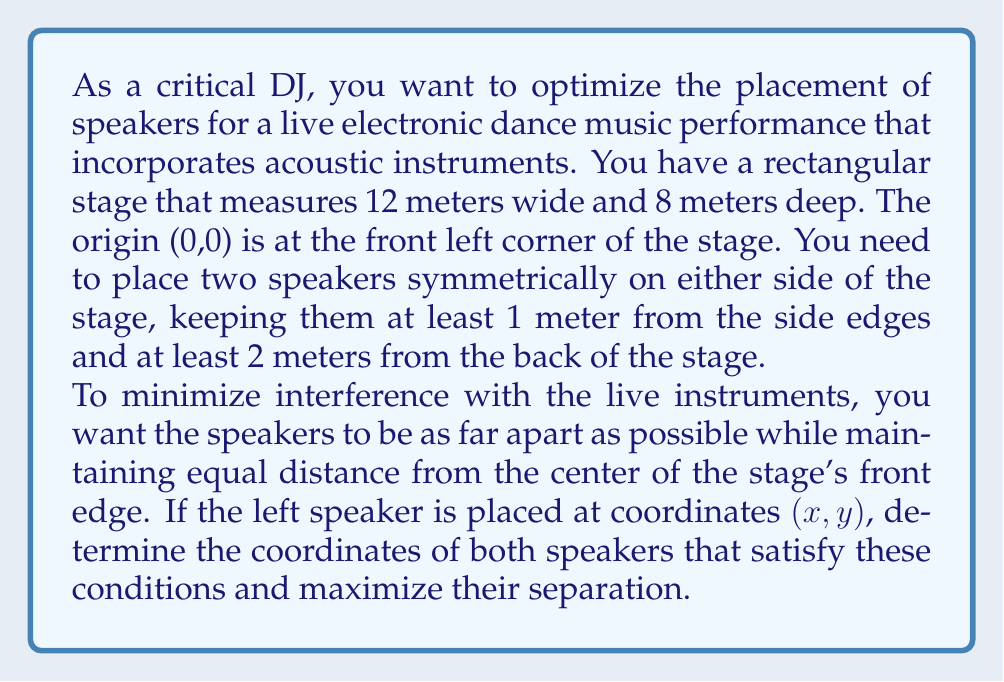Teach me how to tackle this problem. Let's approach this step-by-step:

1) The stage is 12 meters wide and 8 meters deep. The center of the front edge is at (6, 0).

2) Let the left speaker be at (x, y) and the right speaker at (12-x, y) to maintain symmetry.

3) Constraints:
   - x ≥ 1 (at least 1 meter from left edge)
   - 12-x ≥ 1 → x ≤ 11 (at least 1 meter from right edge)
   - y ≤ 6 (at least 2 meters from back edge)

4) To maximize separation, we want to maximize (12-x) - x = 12 - 2x
   This occurs when x is at its minimum value, x = 1

5) Now we need to ensure both speakers are equidistant from (6, 0):

   $$ \sqrt{(1-6)^2 + y^2} = \sqrt{(11-6)^2 + y^2} $$

6) Simplifying:
   $$ \sqrt{25 + y^2} = \sqrt{25 + y^2} $$

   This is always true, so any y value that satisfies the constraint y ≤ 6 will work.

7) To maximize the distance from the front of the stage (and thus from the live instruments), we choose y = 6.

Therefore, the optimal coordinates are (1, 6) for the left speaker and (11, 6) for the right speaker.
Answer: Left speaker: (1, 6)
Right speaker: (11, 6) 